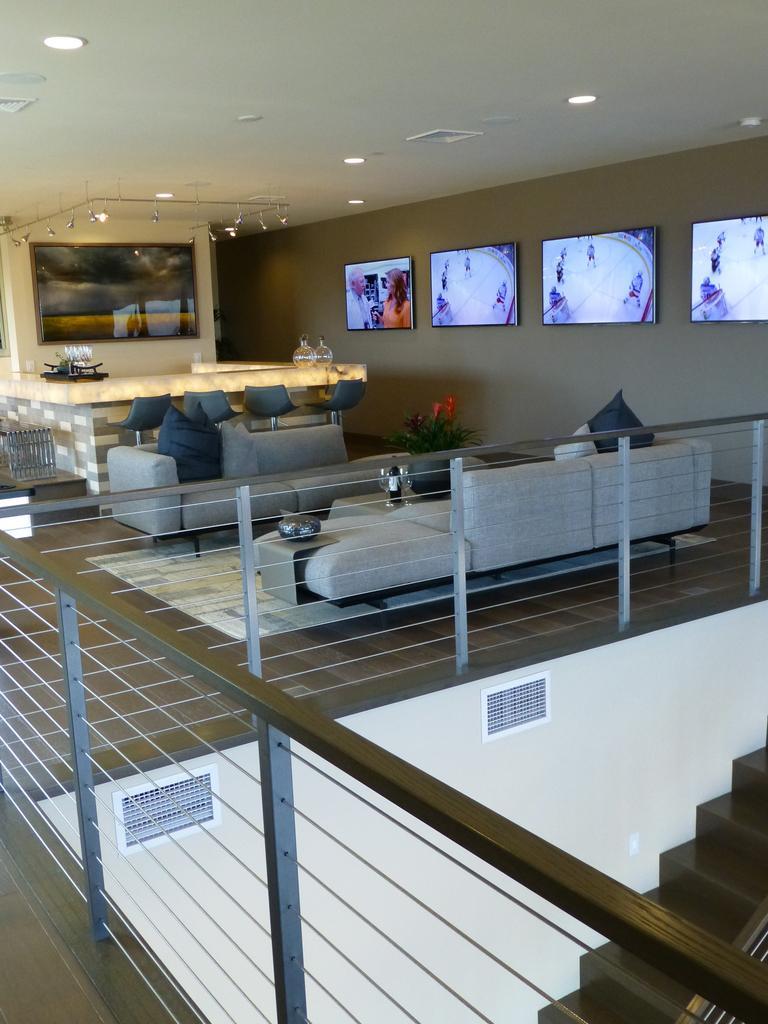Describe this image in one or two sentences. n this picture we can see two sofas and pillows on it. And a table in between two sofas. And we can see four chairs. To the right corner we can see four tv screens. And a small plant with flower. And to the left corner there is frame. And to the bottom right corner there are steps. 